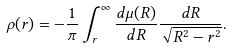<formula> <loc_0><loc_0><loc_500><loc_500>\rho ( r ) = - \frac { 1 } { \pi } \int _ { r } ^ { \infty } \frac { d \mu ( R ) } { d R } \frac { d R } { \sqrt { R ^ { 2 } - r ^ { 2 } } } .</formula> 